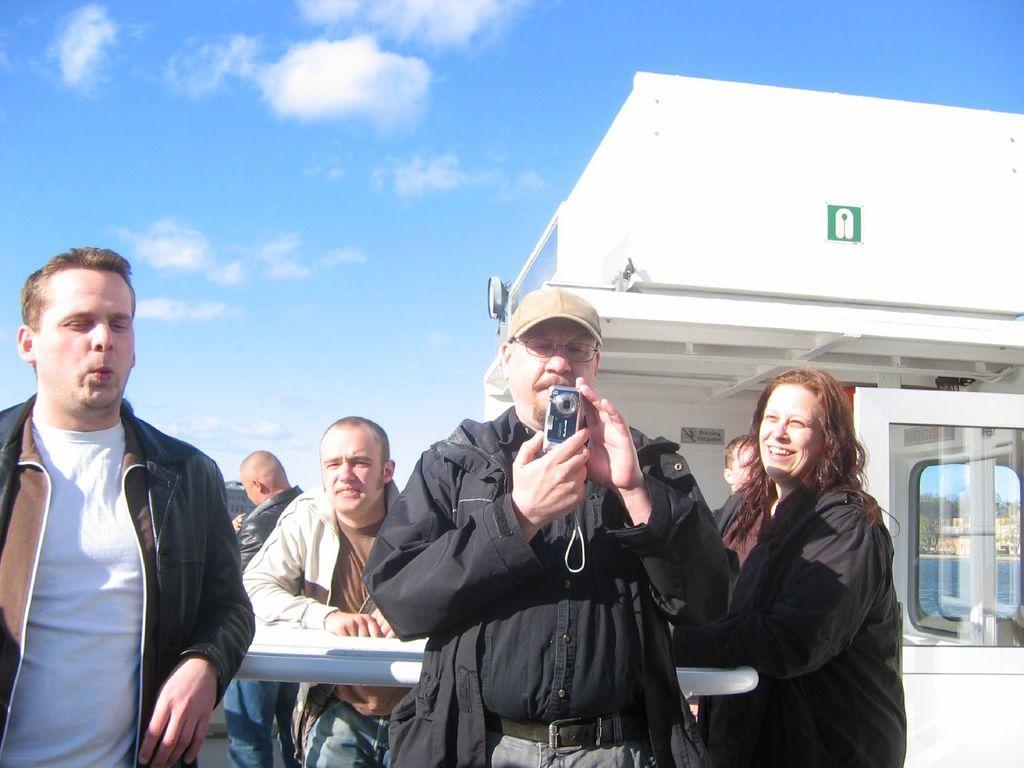Could you give a brief overview of what you see in this image? In the picture I can see a person wearing black jacket is standing and holding a camera in his hands and there is a person standing on either sides of him and there are few other persons behind them and there are some other objects in the background. 